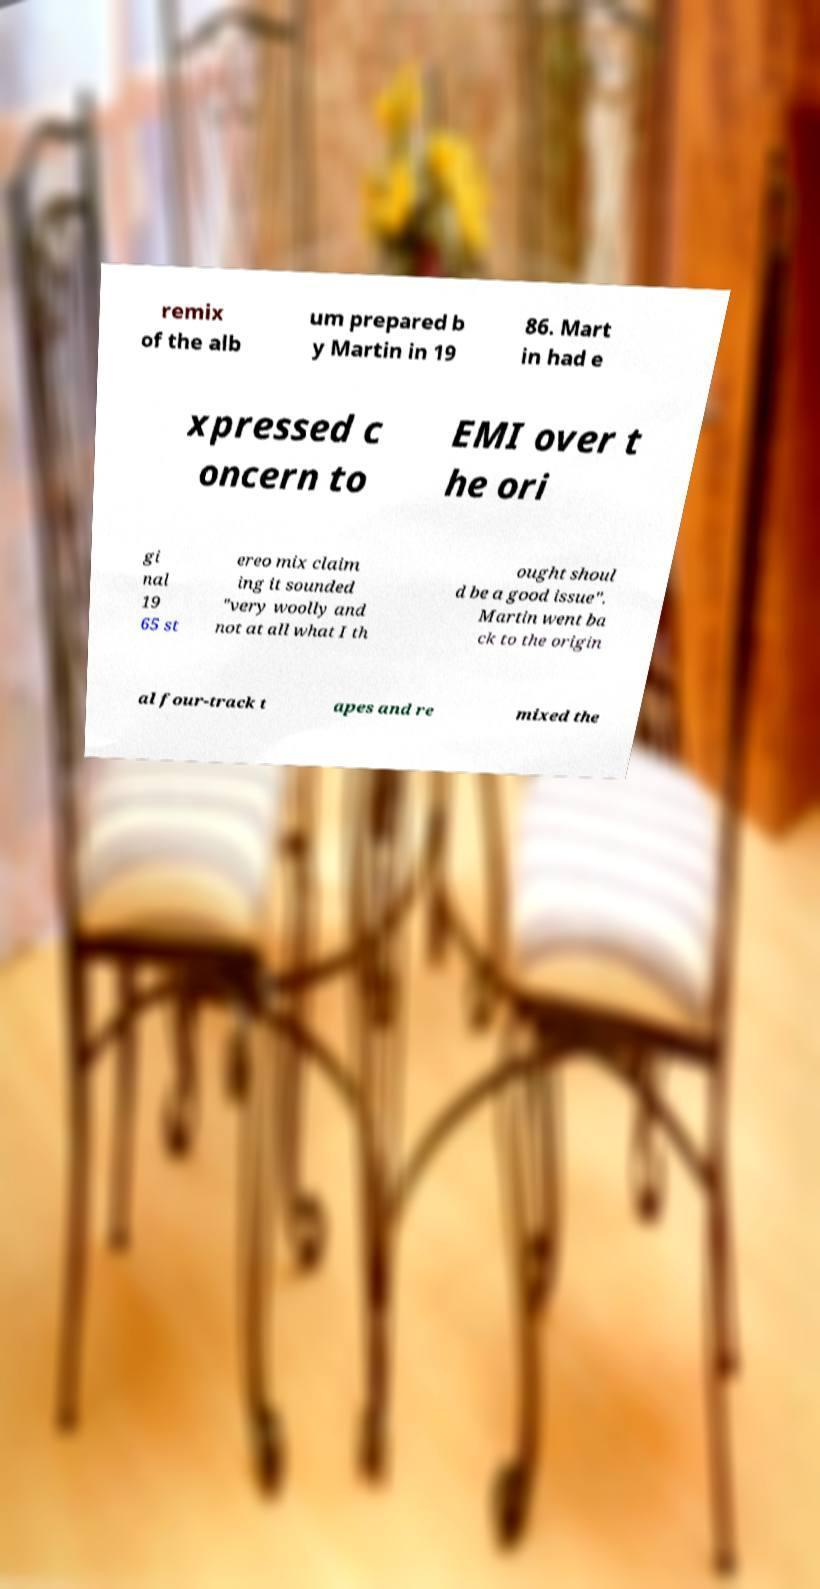Could you extract and type out the text from this image? remix of the alb um prepared b y Martin in 19 86. Mart in had e xpressed c oncern to EMI over t he ori gi nal 19 65 st ereo mix claim ing it sounded "very woolly and not at all what I th ought shoul d be a good issue". Martin went ba ck to the origin al four-track t apes and re mixed the 